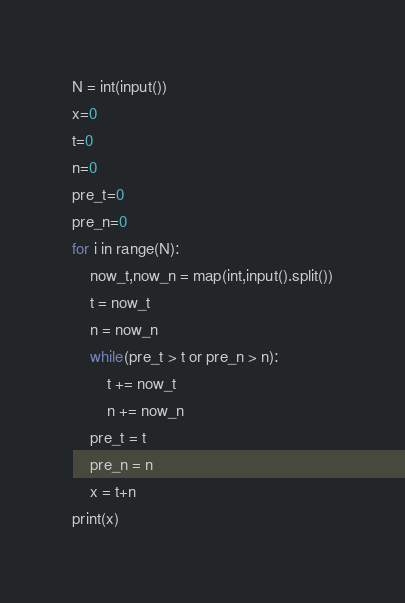Convert code to text. <code><loc_0><loc_0><loc_500><loc_500><_Python_>N = int(input())
x=0
t=0
n=0
pre_t=0
pre_n=0
for i in range(N):
    now_t,now_n = map(int,input().split())
    t = now_t
    n = now_n
    while(pre_t > t or pre_n > n):
        t += now_t
        n += now_n
    pre_t = t
    pre_n = n
    x = t+n
print(x)</code> 